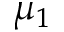Convert formula to latex. <formula><loc_0><loc_0><loc_500><loc_500>\mu _ { 1 }</formula> 